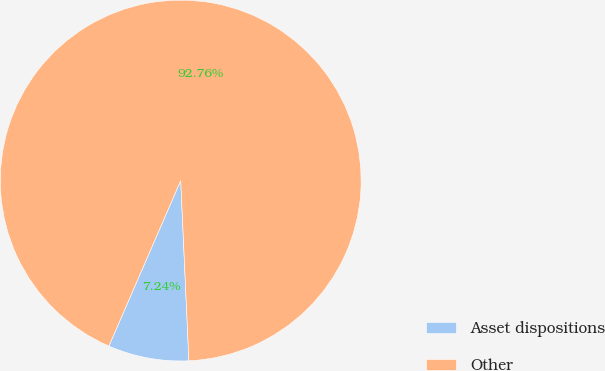Convert chart to OTSL. <chart><loc_0><loc_0><loc_500><loc_500><pie_chart><fcel>Asset dispositions<fcel>Other<nl><fcel>7.24%<fcel>92.76%<nl></chart> 